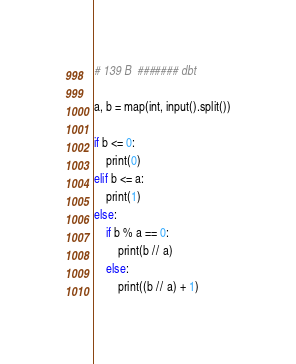<code> <loc_0><loc_0><loc_500><loc_500><_Python_># 139 B  ####### dbt

a, b = map(int, input().split())

if b <= 0:
    print(0)
elif b <= a:
    print(1)
else:
    if b % a == 0:
        print(b // a)
    else:
        print((b // a) + 1)
</code> 